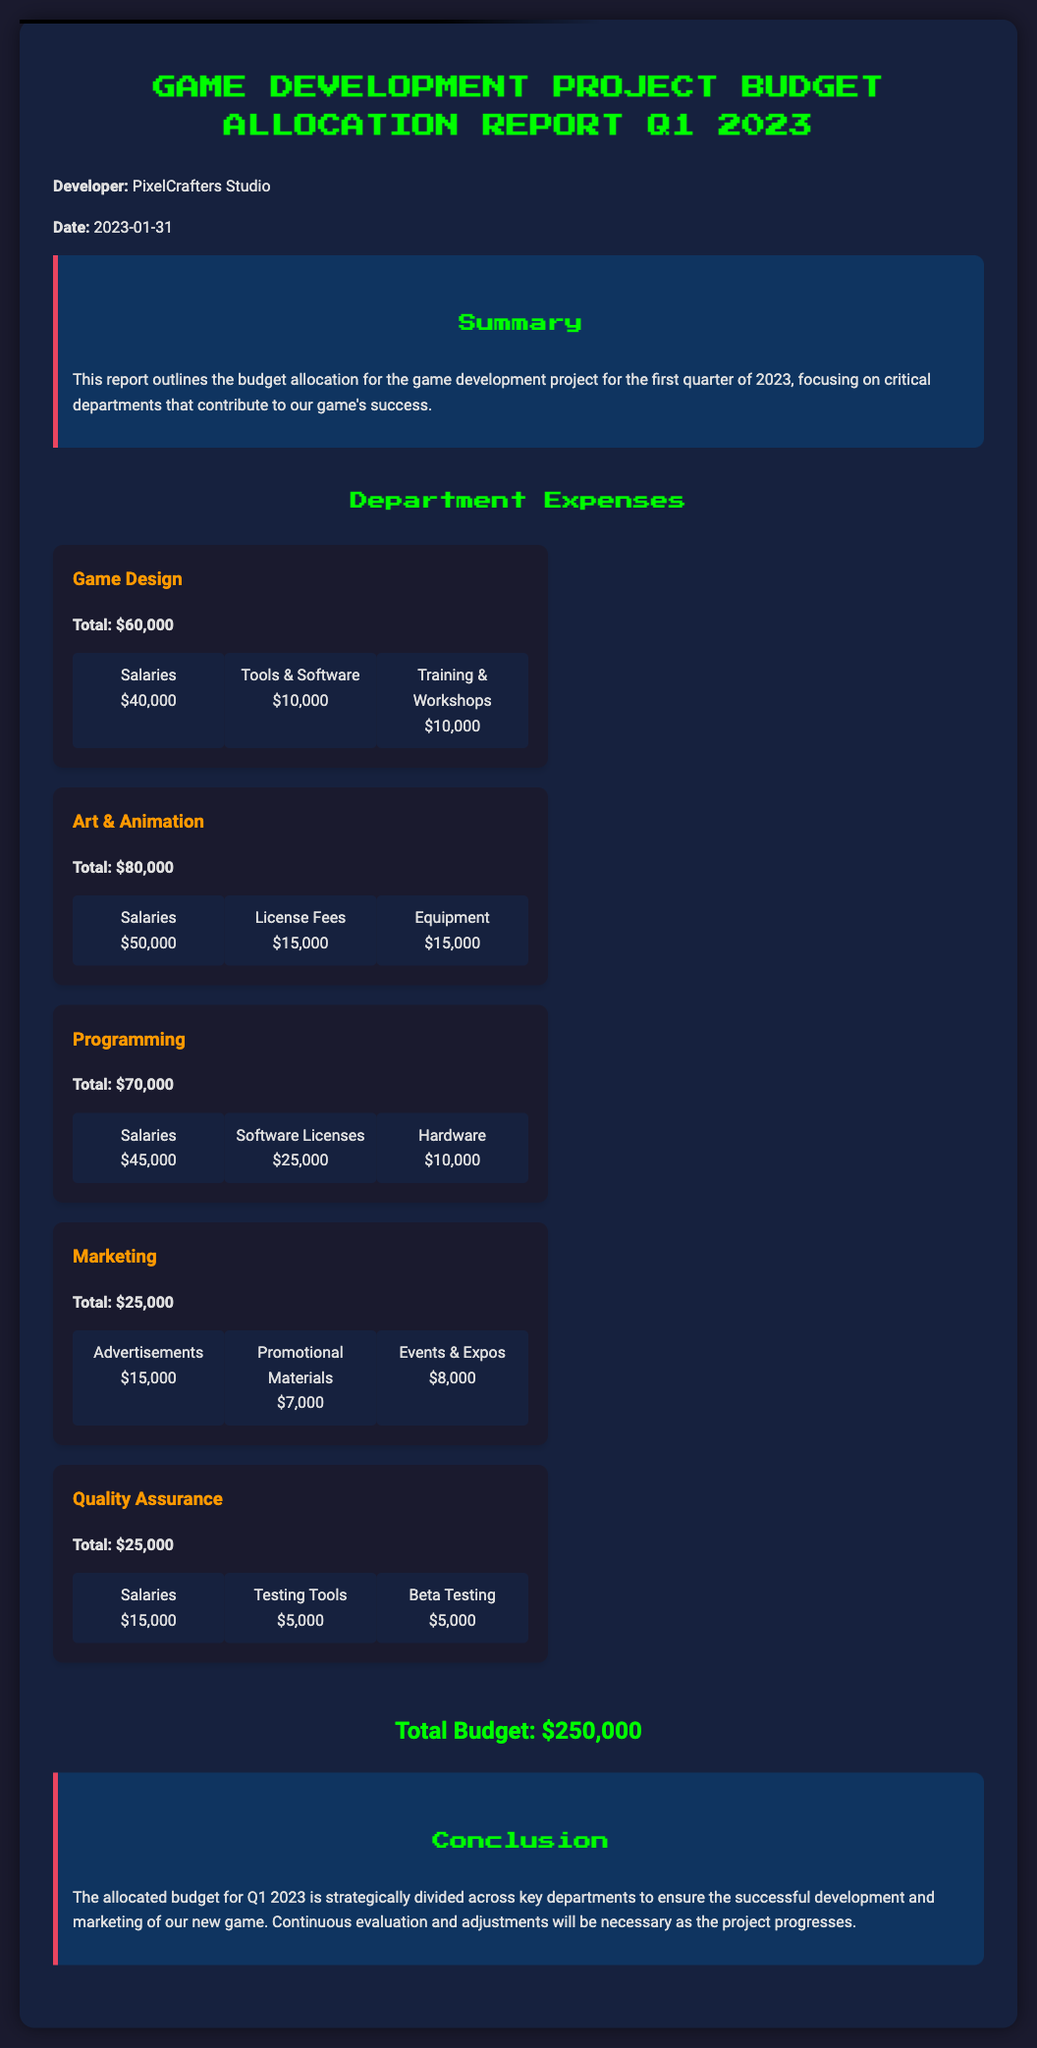What is the total budget for Q1 2023? The total budget is indicated at the end of the report, which summarizes all department allocations.
Answer: $250,000 What is the total expense for the Game Design department? The total expense for the Game Design department is clearly stated under that section.
Answer: $60,000 How much is allocated for Art & Animation salaries? The salaries for the Art & Animation department are broken down and specified.
Answer: $50,000 What are the two largest expense categories in the Programming department? The main expenses categories listed in Programming are Salaries and Software Licenses, and their values are indicated.
Answer: Salaries, Software Licenses Which department has the lowest total budget in this report? By comparing the total amounts allocated to each department, we can find the one with the lowest total.
Answer: Marketing, Quality Assurance What is the total amount allocated to Marketing for advertisements? This specific expense is outlined as part of the Marketing budget in the respective section.
Answer: $15,000 